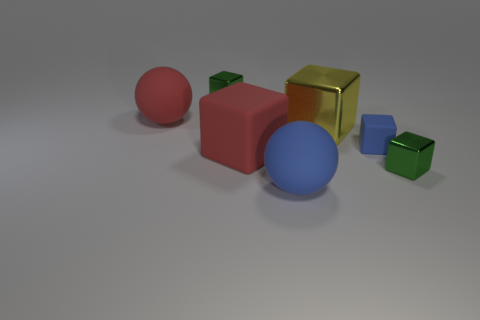How many balls have the same color as the small rubber object?
Your response must be concise. 1. What is the size of the other rubber thing that is the same color as the small rubber thing?
Your response must be concise. Large. Do the small cube that is behind the big metal object and the big cube that is to the left of the large blue rubber sphere have the same material?
Your answer should be compact. No. How many things are yellow objects or small shiny cubes that are left of the big blue matte sphere?
Keep it short and to the point. 2. Is there anything else that is the same material as the tiny blue object?
Give a very brief answer. Yes. There is another rubber thing that is the same color as the tiny matte thing; what shape is it?
Your response must be concise. Sphere. What material is the blue sphere?
Give a very brief answer. Rubber. Is the material of the yellow block the same as the blue cube?
Keep it short and to the point. No. What number of matte objects are either small objects or small cyan objects?
Make the answer very short. 1. There is a green metallic thing that is behind the blue block; what is its shape?
Offer a terse response. Cube. 